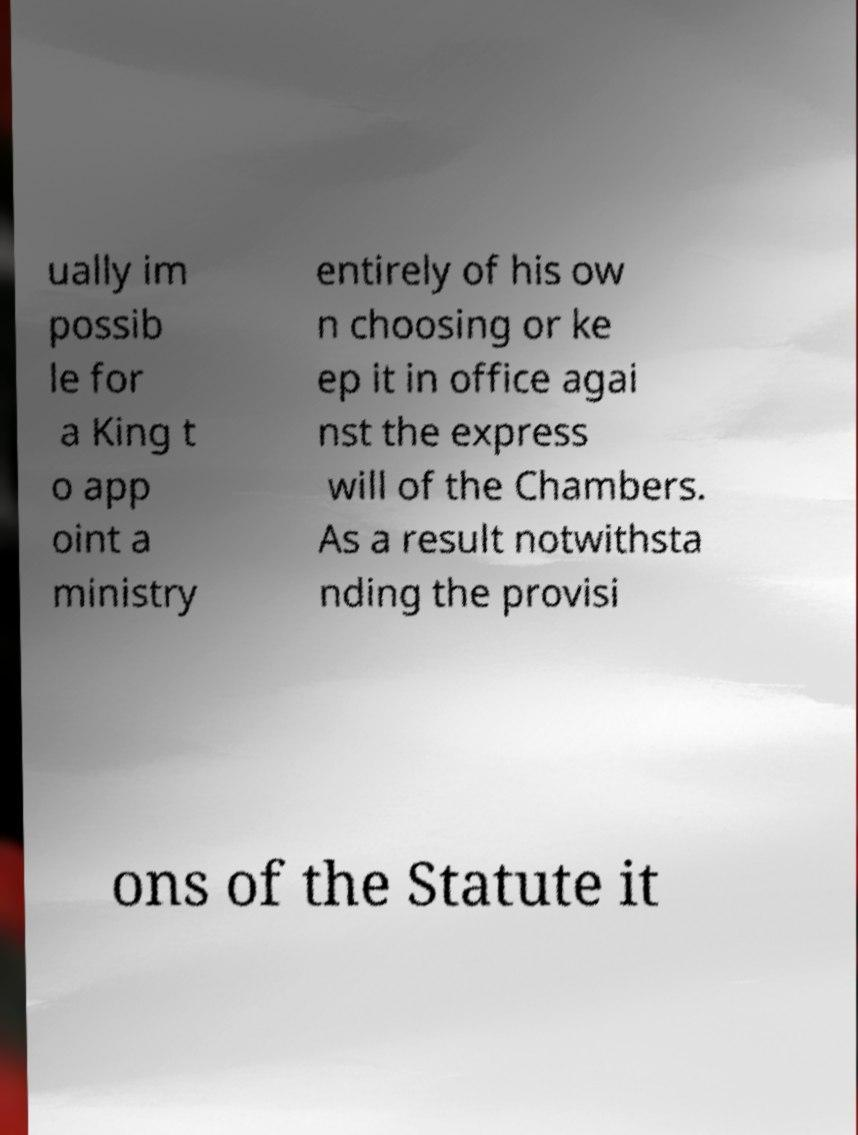Please read and relay the text visible in this image. What does it say? ually im possib le for a King t o app oint a ministry entirely of his ow n choosing or ke ep it in office agai nst the express will of the Chambers. As a result notwithsta nding the provisi ons of the Statute it 